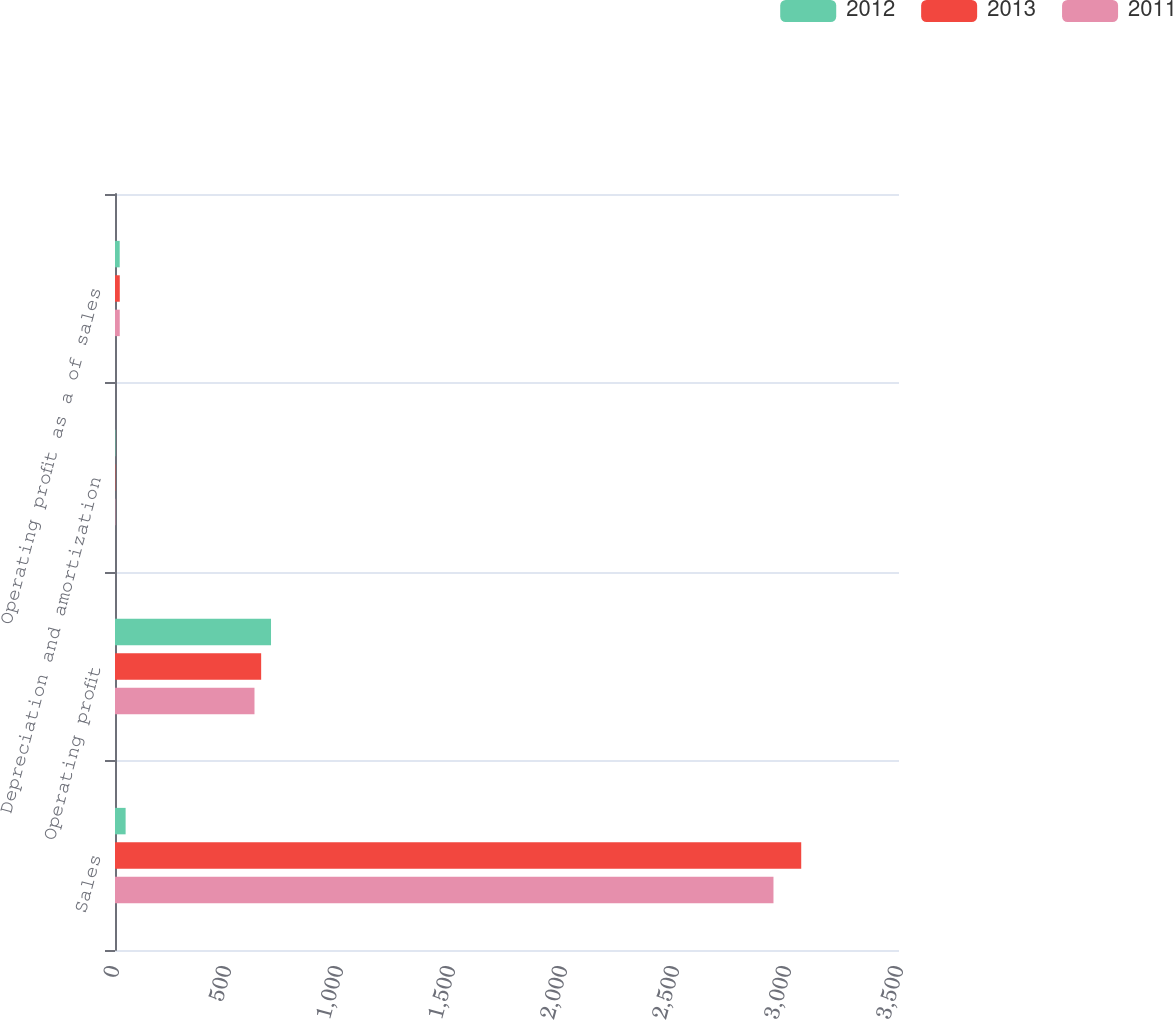Convert chart. <chart><loc_0><loc_0><loc_500><loc_500><stacked_bar_chart><ecel><fcel>Sales<fcel>Operating profit<fcel>Depreciation and amortization<fcel>Operating profit as a of sales<nl><fcel>2012<fcel>47.4<fcel>696.5<fcel>1.9<fcel>21<nl><fcel>2013<fcel>3063.5<fcel>652.5<fcel>1.6<fcel>21.3<nl><fcel>2011<fcel>2939.6<fcel>622.7<fcel>1.6<fcel>21.2<nl></chart> 